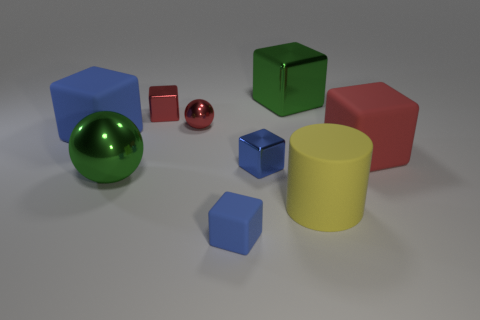There is a tiny thing that is the same color as the tiny rubber block; what is its material?
Provide a succinct answer. Metal. How big is the cylinder?
Provide a succinct answer. Large. What number of matte things are blue objects or brown objects?
Give a very brief answer. 2. Are there fewer big red objects than cyan shiny cubes?
Provide a short and direct response. No. How many other things are the same material as the large red object?
Your answer should be very brief. 3. There is a blue metal thing that is the same shape as the big red matte object; what size is it?
Keep it short and to the point. Small. Is the large block that is to the right of the yellow rubber cylinder made of the same material as the large green thing in front of the red metal ball?
Provide a short and direct response. No. Are there fewer green things that are in front of the small red shiny block than red shiny objects?
Make the answer very short. Yes. Is there anything else that has the same shape as the large red rubber object?
Give a very brief answer. Yes. The small matte object that is the same shape as the blue metallic thing is what color?
Keep it short and to the point. Blue. 